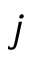<formula> <loc_0><loc_0><loc_500><loc_500>j</formula> 